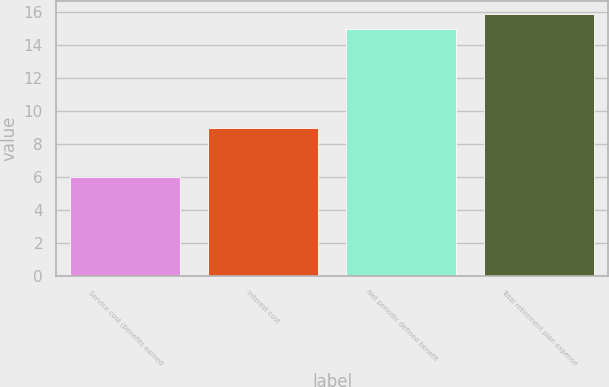Convert chart. <chart><loc_0><loc_0><loc_500><loc_500><bar_chart><fcel>Service cost (benefits earned<fcel>Interest cost<fcel>Net periodic defined benefit<fcel>Total retirement plan expense<nl><fcel>6<fcel>9<fcel>15<fcel>15.9<nl></chart> 